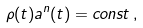Convert formula to latex. <formula><loc_0><loc_0><loc_500><loc_500>\rho ( t ) a ^ { n } ( t ) = c o n s t \, ,</formula> 